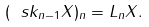Convert formula to latex. <formula><loc_0><loc_0><loc_500><loc_500>( \ s k _ { n - 1 } X ) _ { n } = L _ { n } X .</formula> 